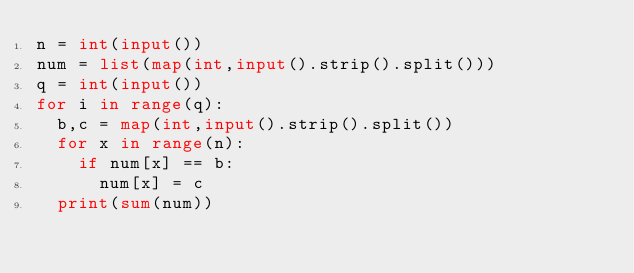Convert code to text. <code><loc_0><loc_0><loc_500><loc_500><_Python_>n = int(input())
num = list(map(int,input().strip().split()))
q = int(input())
for i in range(q):
  b,c = map(int,input().strip().split())
  for x in range(n):
    if num[x] == b:
      num[x] = c
  print(sum(num))</code> 